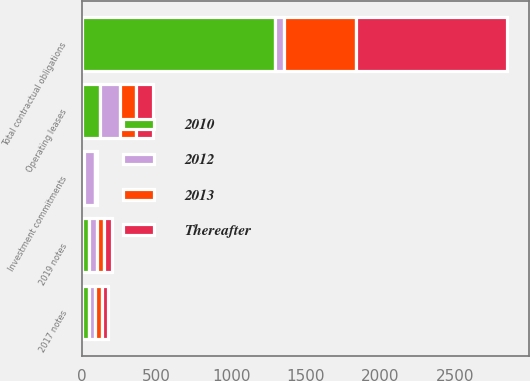Convert chart. <chart><loc_0><loc_0><loc_500><loc_500><stacked_bar_chart><ecel><fcel>2017 notes<fcel>2019 notes<fcel>Operating leases<fcel>Investment commitments<fcel>Total contractual obligations<nl><fcel>2012<fcel>44<fcel>50<fcel>135<fcel>70<fcel>60<nl><fcel>2010<fcel>44<fcel>50<fcel>121<fcel>16<fcel>1295<nl><fcel>Thereafter<fcel>44<fcel>50<fcel>111<fcel>11<fcel>1015<nl><fcel>2013<fcel>44<fcel>50<fcel>108<fcel>4<fcel>484<nl></chart> 